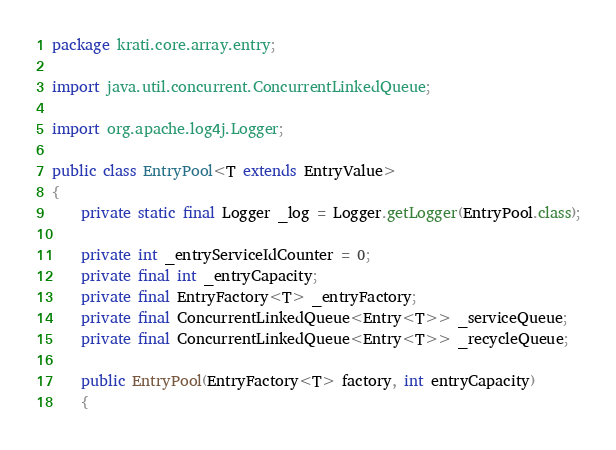Convert code to text. <code><loc_0><loc_0><loc_500><loc_500><_Java_>package krati.core.array.entry;

import java.util.concurrent.ConcurrentLinkedQueue;

import org.apache.log4j.Logger;

public class EntryPool<T extends EntryValue>
{
    private static final Logger _log = Logger.getLogger(EntryPool.class);
    
    private int _entryServiceIdCounter = 0;
    private final int _entryCapacity;
    private final EntryFactory<T> _entryFactory;
    private final ConcurrentLinkedQueue<Entry<T>> _serviceQueue;
    private final ConcurrentLinkedQueue<Entry<T>> _recycleQueue;
    
    public EntryPool(EntryFactory<T> factory, int entryCapacity)
    {</code> 